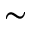<formula> <loc_0><loc_0><loc_500><loc_500>\sim</formula> 